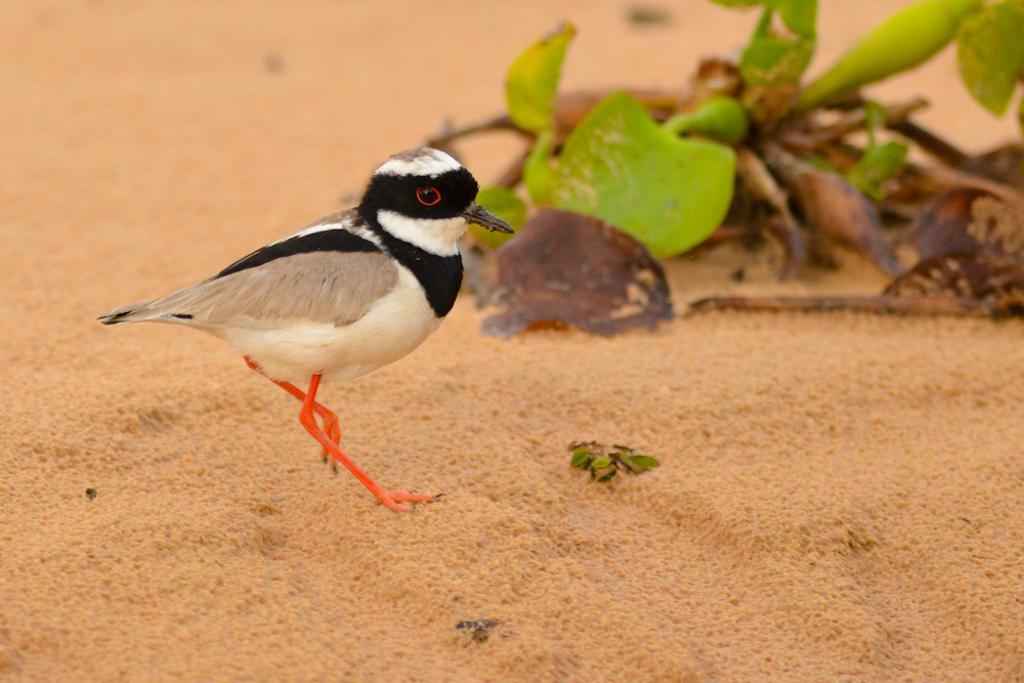Describe this image in one or two sentences. In this image we can see a bird on the ground. In the background, we can see some leaves. 